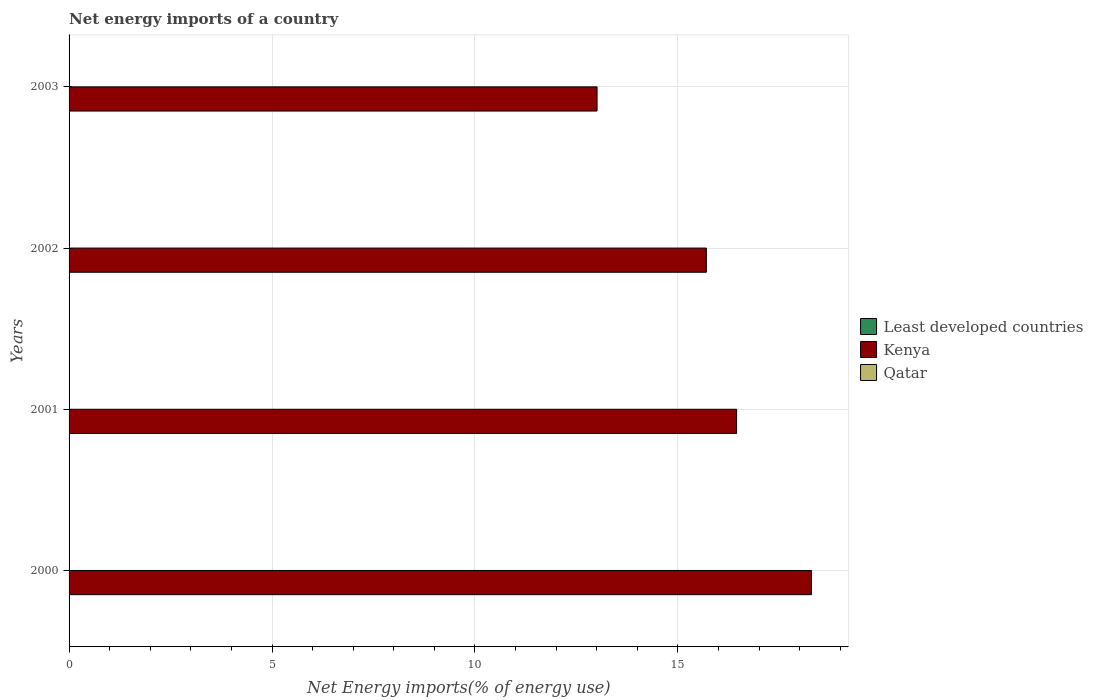Are the number of bars per tick equal to the number of legend labels?
Offer a terse response. No. Are the number of bars on each tick of the Y-axis equal?
Offer a very short reply. Yes. How many bars are there on the 3rd tick from the top?
Provide a succinct answer. 1. How many bars are there on the 4th tick from the bottom?
Provide a short and direct response. 1. In how many cases, is the number of bars for a given year not equal to the number of legend labels?
Offer a very short reply. 4. What is the net energy imports in Kenya in 2000?
Your answer should be very brief. 18.29. Across all years, what is the maximum net energy imports in Kenya?
Give a very brief answer. 18.29. What is the total net energy imports in Qatar in the graph?
Ensure brevity in your answer.  0. What is the difference between the net energy imports in Kenya in 2002 and that in 2003?
Provide a succinct answer. 2.69. What is the difference between the net energy imports in Kenya in 2000 and the net energy imports in Qatar in 2002?
Give a very brief answer. 18.29. What is the average net energy imports in Qatar per year?
Keep it short and to the point. 0. In how many years, is the net energy imports in Kenya greater than 15 %?
Your response must be concise. 3. What is the ratio of the net energy imports in Kenya in 2001 to that in 2002?
Provide a short and direct response. 1.05. What is the difference between the highest and the second highest net energy imports in Kenya?
Give a very brief answer. 1.84. What is the difference between the highest and the lowest net energy imports in Kenya?
Provide a succinct answer. 5.28. Is it the case that in every year, the sum of the net energy imports in Qatar and net energy imports in Kenya is greater than the net energy imports in Least developed countries?
Offer a very short reply. Yes. What is the difference between two consecutive major ticks on the X-axis?
Keep it short and to the point. 5. Are the values on the major ticks of X-axis written in scientific E-notation?
Ensure brevity in your answer.  No. Does the graph contain any zero values?
Your answer should be compact. Yes. Where does the legend appear in the graph?
Your response must be concise. Center right. How many legend labels are there?
Your answer should be compact. 3. What is the title of the graph?
Keep it short and to the point. Net energy imports of a country. What is the label or title of the X-axis?
Offer a very short reply. Net Energy imports(% of energy use). What is the label or title of the Y-axis?
Offer a terse response. Years. What is the Net Energy imports(% of energy use) of Kenya in 2000?
Ensure brevity in your answer.  18.29. What is the Net Energy imports(% of energy use) of Kenya in 2001?
Your answer should be compact. 16.45. What is the Net Energy imports(% of energy use) of Least developed countries in 2002?
Offer a terse response. 0. What is the Net Energy imports(% of energy use) in Kenya in 2002?
Give a very brief answer. 15.7. What is the Net Energy imports(% of energy use) of Qatar in 2002?
Your answer should be compact. 0. What is the Net Energy imports(% of energy use) in Least developed countries in 2003?
Your response must be concise. 0. What is the Net Energy imports(% of energy use) in Kenya in 2003?
Your answer should be very brief. 13.01. What is the Net Energy imports(% of energy use) in Qatar in 2003?
Give a very brief answer. 0. Across all years, what is the maximum Net Energy imports(% of energy use) of Kenya?
Keep it short and to the point. 18.29. Across all years, what is the minimum Net Energy imports(% of energy use) in Kenya?
Make the answer very short. 13.01. What is the total Net Energy imports(% of energy use) of Kenya in the graph?
Make the answer very short. 63.45. What is the total Net Energy imports(% of energy use) of Qatar in the graph?
Your answer should be very brief. 0. What is the difference between the Net Energy imports(% of energy use) of Kenya in 2000 and that in 2001?
Offer a terse response. 1.84. What is the difference between the Net Energy imports(% of energy use) in Kenya in 2000 and that in 2002?
Your answer should be very brief. 2.59. What is the difference between the Net Energy imports(% of energy use) in Kenya in 2000 and that in 2003?
Give a very brief answer. 5.28. What is the difference between the Net Energy imports(% of energy use) in Kenya in 2001 and that in 2002?
Provide a short and direct response. 0.75. What is the difference between the Net Energy imports(% of energy use) in Kenya in 2001 and that in 2003?
Provide a succinct answer. 3.44. What is the difference between the Net Energy imports(% of energy use) of Kenya in 2002 and that in 2003?
Your answer should be compact. 2.69. What is the average Net Energy imports(% of energy use) of Least developed countries per year?
Ensure brevity in your answer.  0. What is the average Net Energy imports(% of energy use) in Kenya per year?
Your answer should be compact. 15.86. What is the ratio of the Net Energy imports(% of energy use) of Kenya in 2000 to that in 2001?
Offer a very short reply. 1.11. What is the ratio of the Net Energy imports(% of energy use) of Kenya in 2000 to that in 2002?
Make the answer very short. 1.16. What is the ratio of the Net Energy imports(% of energy use) of Kenya in 2000 to that in 2003?
Offer a terse response. 1.41. What is the ratio of the Net Energy imports(% of energy use) of Kenya in 2001 to that in 2002?
Offer a very short reply. 1.05. What is the ratio of the Net Energy imports(% of energy use) of Kenya in 2001 to that in 2003?
Your answer should be very brief. 1.26. What is the ratio of the Net Energy imports(% of energy use) in Kenya in 2002 to that in 2003?
Your answer should be very brief. 1.21. What is the difference between the highest and the second highest Net Energy imports(% of energy use) in Kenya?
Provide a short and direct response. 1.84. What is the difference between the highest and the lowest Net Energy imports(% of energy use) of Kenya?
Provide a short and direct response. 5.28. 